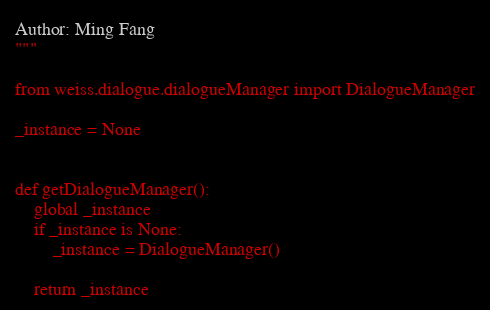Convert code to text. <code><loc_0><loc_0><loc_500><loc_500><_Python_>Author: Ming Fang
"""

from weiss.dialogue.dialogueManager import DialogueManager

_instance = None


def getDialogueManager():
    global _instance
    if _instance is None:
        _instance = DialogueManager()

    return _instance
</code> 